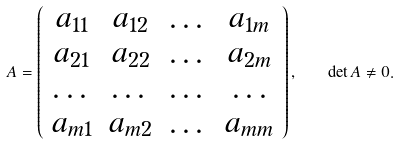Convert formula to latex. <formula><loc_0><loc_0><loc_500><loc_500>A = \left ( \begin{array} { c c c c } a _ { 1 1 } & a _ { 1 2 } & \dots & a _ { 1 m } \\ a _ { 2 1 } & a _ { 2 2 } & \dots & a _ { 2 m } \\ \dots & \dots & \dots & \dots \\ a _ { m 1 } & a _ { m 2 } & \dots & a _ { m m } \end{array} \right ) , \quad \det A \neq 0 .</formula> 